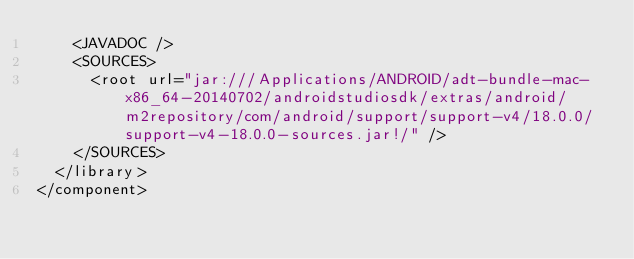<code> <loc_0><loc_0><loc_500><loc_500><_XML_>    <JAVADOC />
    <SOURCES>
      <root url="jar:///Applications/ANDROID/adt-bundle-mac-x86_64-20140702/androidstudiosdk/extras/android/m2repository/com/android/support/support-v4/18.0.0/support-v4-18.0.0-sources.jar!/" />
    </SOURCES>
  </library>
</component></code> 